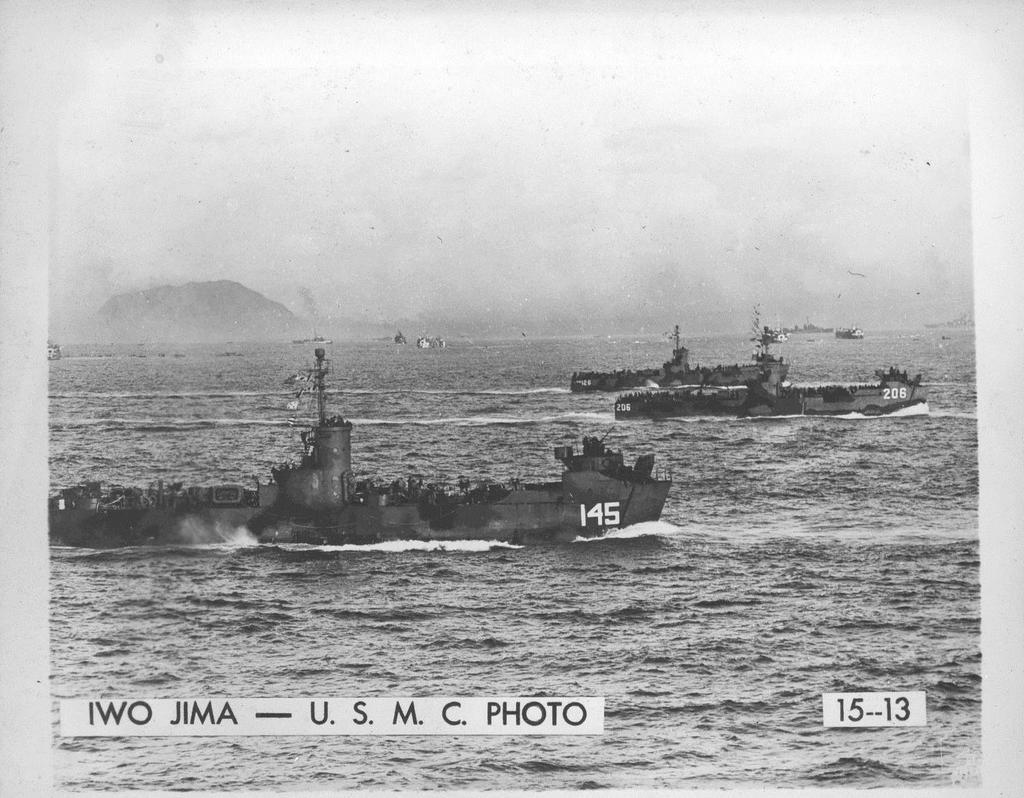<image>
Share a concise interpretation of the image provided. Two ships with the numbers 145 and 206 ride the waves at IWO JIMA 